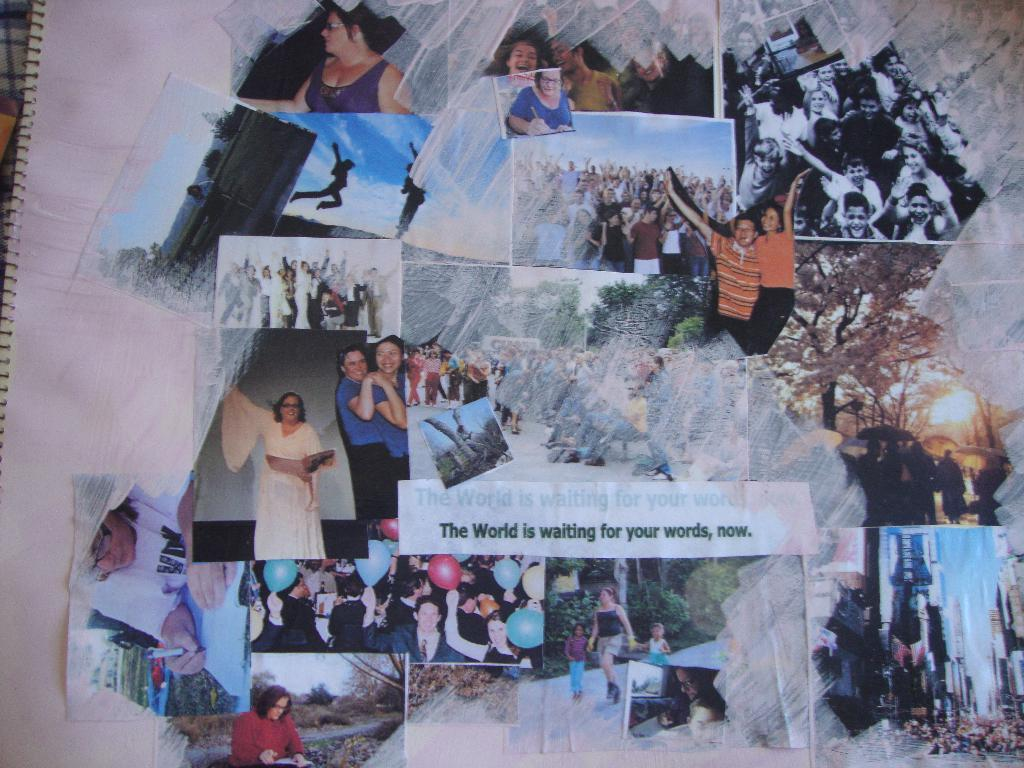Provide a one-sentence caption for the provided image. a page with pictures on it that says 'the world is waiting for your words, now.'. 